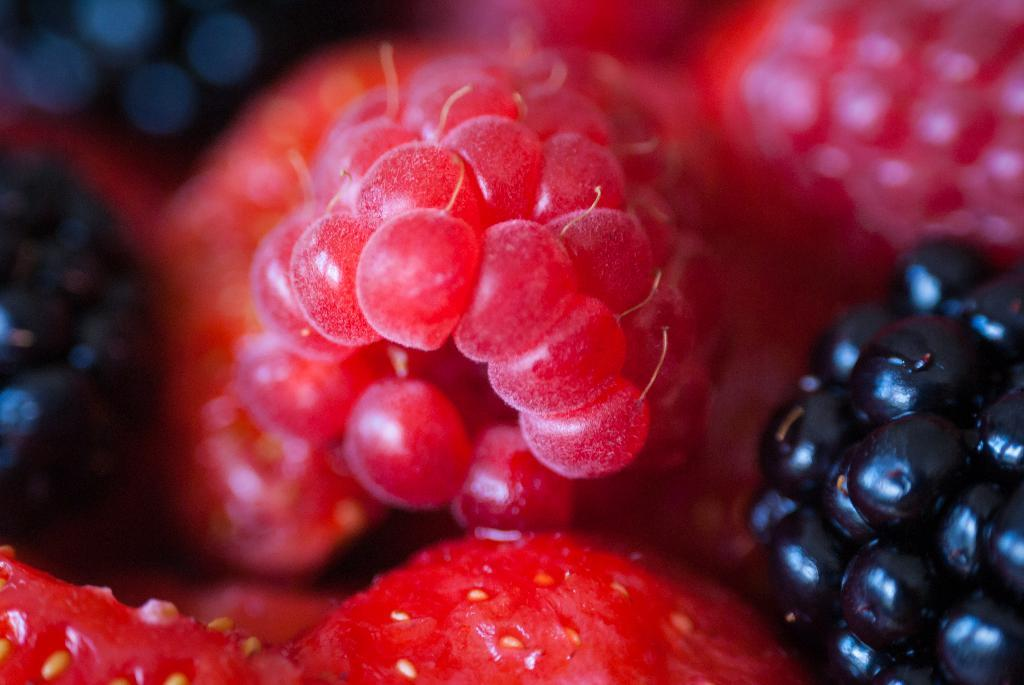What type of food is visible in the image? There are fruits in the image. What color are the red fruits in the image? The red fruits in the image are red in color. What color are the black fruits in the image? The black fruits in the image are black in color. What is the tendency of the plastic to laugh in the image? There is no plastic or laughter present in the image. 